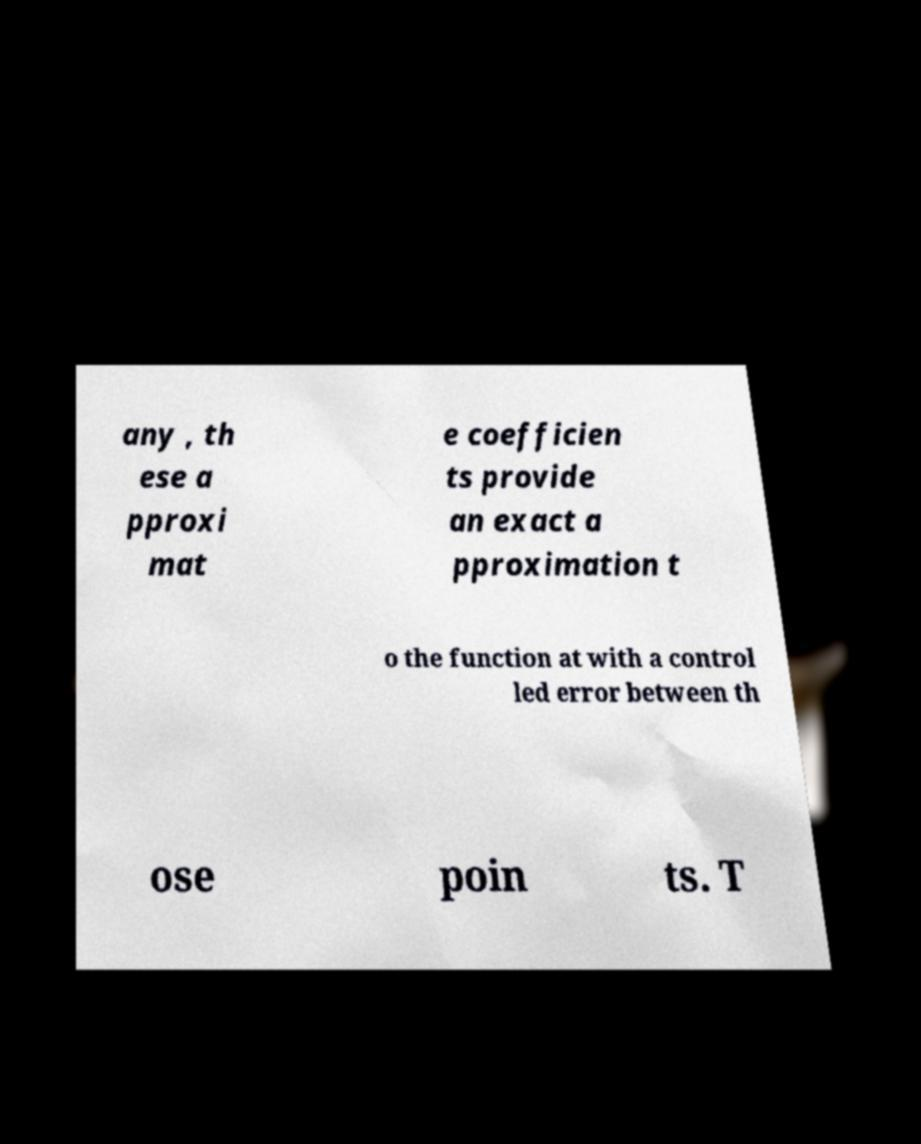Please read and relay the text visible in this image. What does it say? any , th ese a pproxi mat e coefficien ts provide an exact a pproximation t o the function at with a control led error between th ose poin ts. T 